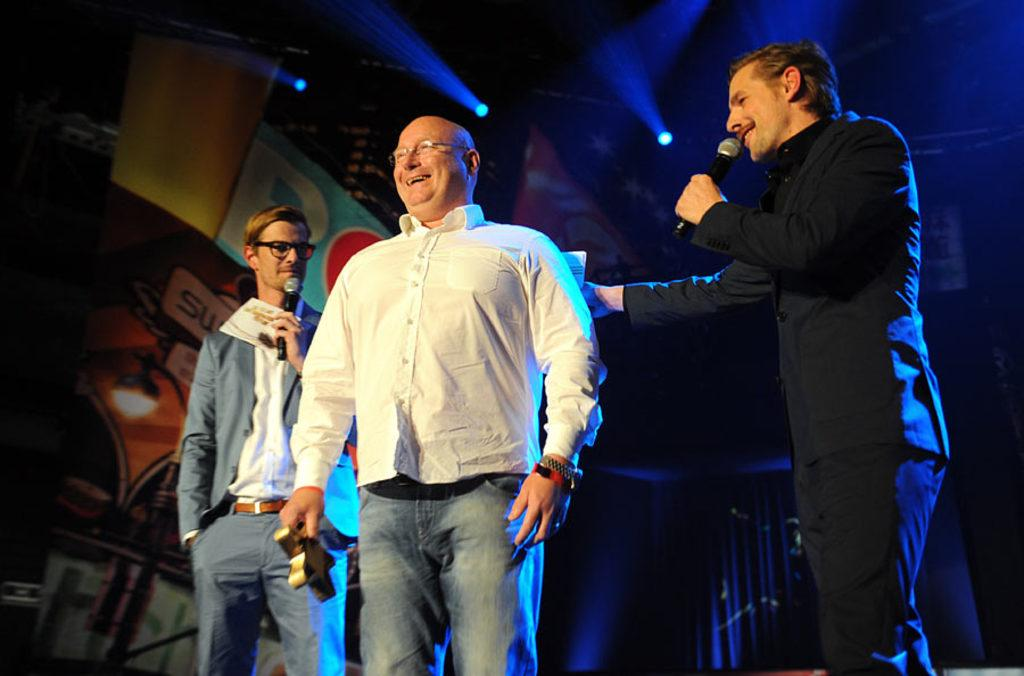What are the people in the middle of the image doing? The people are standing in the middle of the image and holding microphones. What else are the people holding in their hands? The people are holding something in their hands, but it is not specified in the facts. What is the mood of the people in the image? The people are smiling, which suggests a positive or happy mood. What can be seen in the background of the image? There is a banner and lights in the background. Can you tell me how many ovens are visible in the image? There are no ovens present in the image. Do the people in the image have fangs? There is no indication in the image that the people have fangs. 